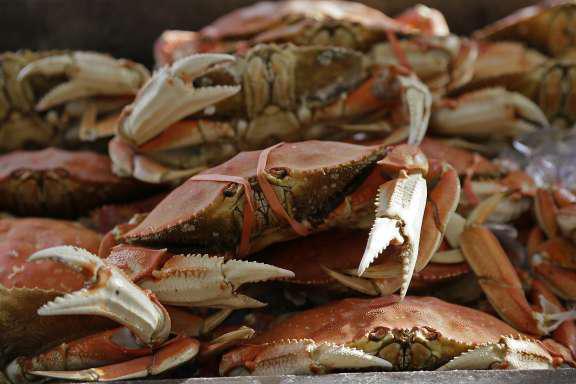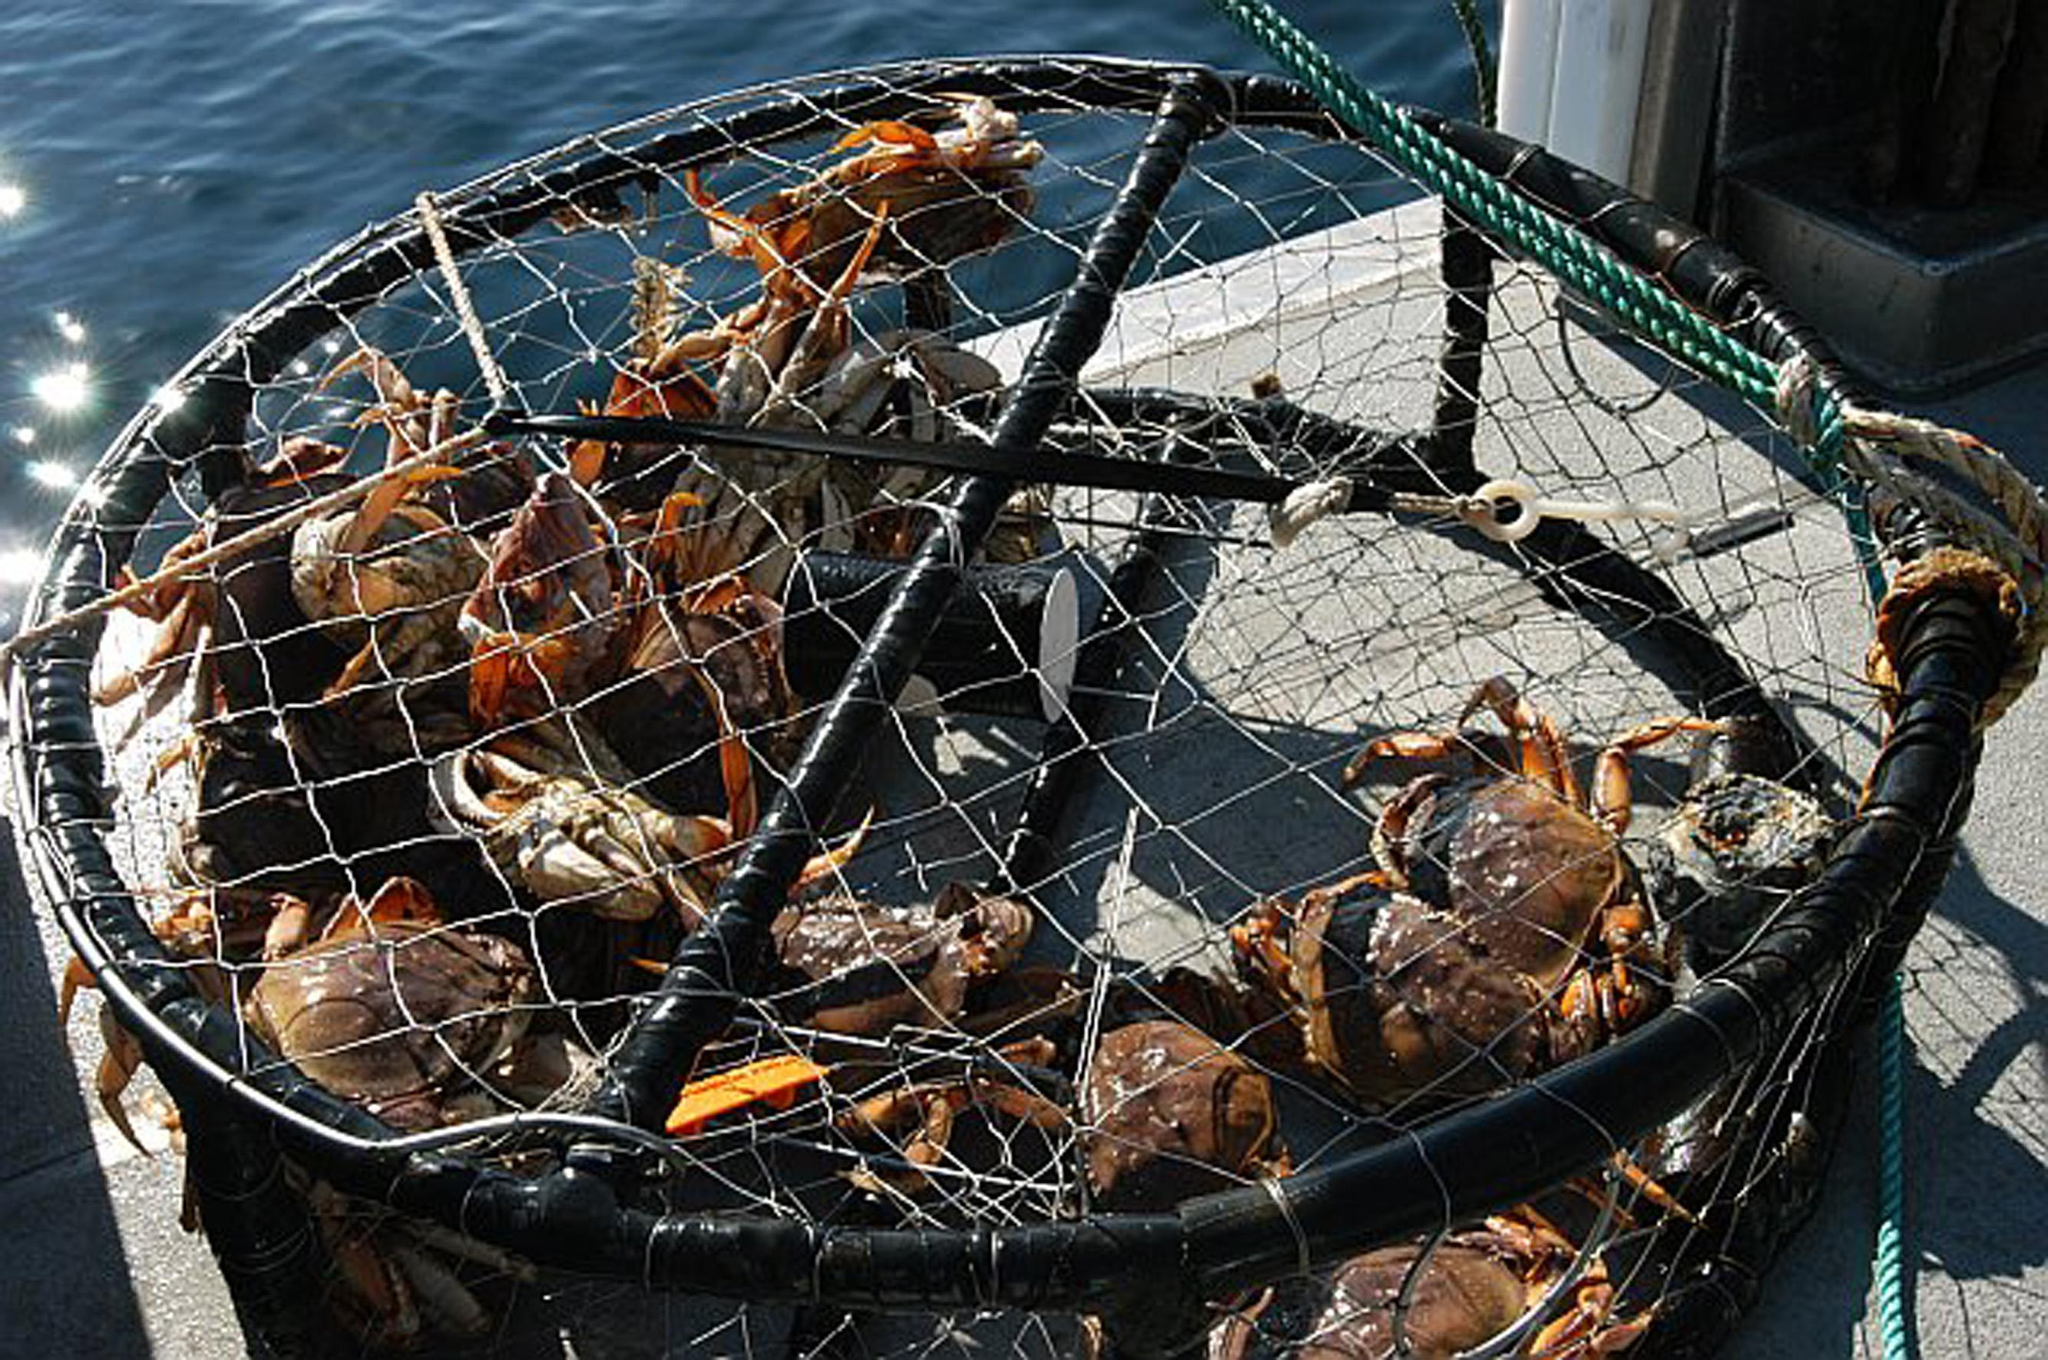The first image is the image on the left, the second image is the image on the right. Examine the images to the left and right. Is the description "The crabs in one of the images are being weighed with a scale." accurate? Answer yes or no. No. The first image is the image on the left, the second image is the image on the right. For the images shown, is this caption "One image shows a pile of shell-side up crabs without a container, and the other image shows a mass of crabs in a round container." true? Answer yes or no. Yes. 